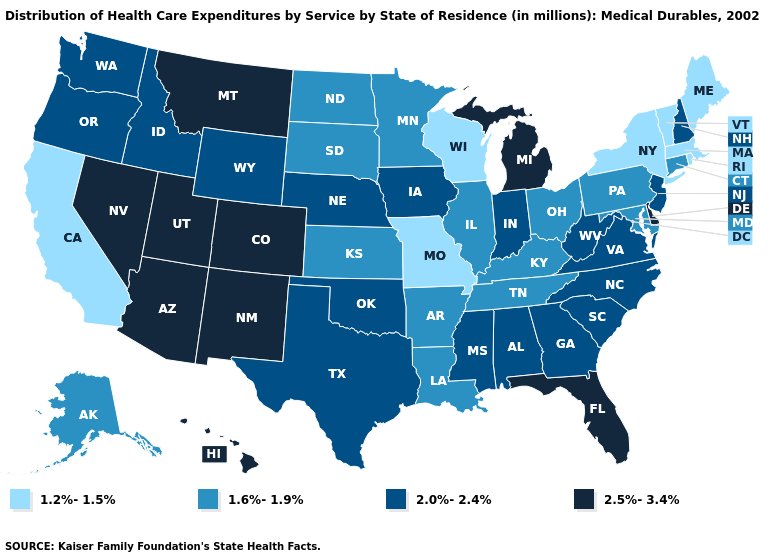Does Nebraska have a higher value than South Dakota?
Short answer required. Yes. Name the states that have a value in the range 1.6%-1.9%?
Concise answer only. Alaska, Arkansas, Connecticut, Illinois, Kansas, Kentucky, Louisiana, Maryland, Minnesota, North Dakota, Ohio, Pennsylvania, South Dakota, Tennessee. Does New Mexico have a lower value than Montana?
Quick response, please. No. Name the states that have a value in the range 1.6%-1.9%?
Write a very short answer. Alaska, Arkansas, Connecticut, Illinois, Kansas, Kentucky, Louisiana, Maryland, Minnesota, North Dakota, Ohio, Pennsylvania, South Dakota, Tennessee. Name the states that have a value in the range 2.5%-3.4%?
Keep it brief. Arizona, Colorado, Delaware, Florida, Hawaii, Michigan, Montana, Nevada, New Mexico, Utah. What is the lowest value in the USA?
Quick response, please. 1.2%-1.5%. What is the value of Wyoming?
Short answer required. 2.0%-2.4%. Which states have the highest value in the USA?
Concise answer only. Arizona, Colorado, Delaware, Florida, Hawaii, Michigan, Montana, Nevada, New Mexico, Utah. Which states have the lowest value in the Northeast?
Answer briefly. Maine, Massachusetts, New York, Rhode Island, Vermont. How many symbols are there in the legend?
Give a very brief answer. 4. What is the value of South Dakota?
Quick response, please. 1.6%-1.9%. Does the first symbol in the legend represent the smallest category?
Keep it brief. Yes. Which states have the lowest value in the Northeast?
Write a very short answer. Maine, Massachusetts, New York, Rhode Island, Vermont. Name the states that have a value in the range 2.5%-3.4%?
Short answer required. Arizona, Colorado, Delaware, Florida, Hawaii, Michigan, Montana, Nevada, New Mexico, Utah. What is the lowest value in the USA?
Quick response, please. 1.2%-1.5%. 